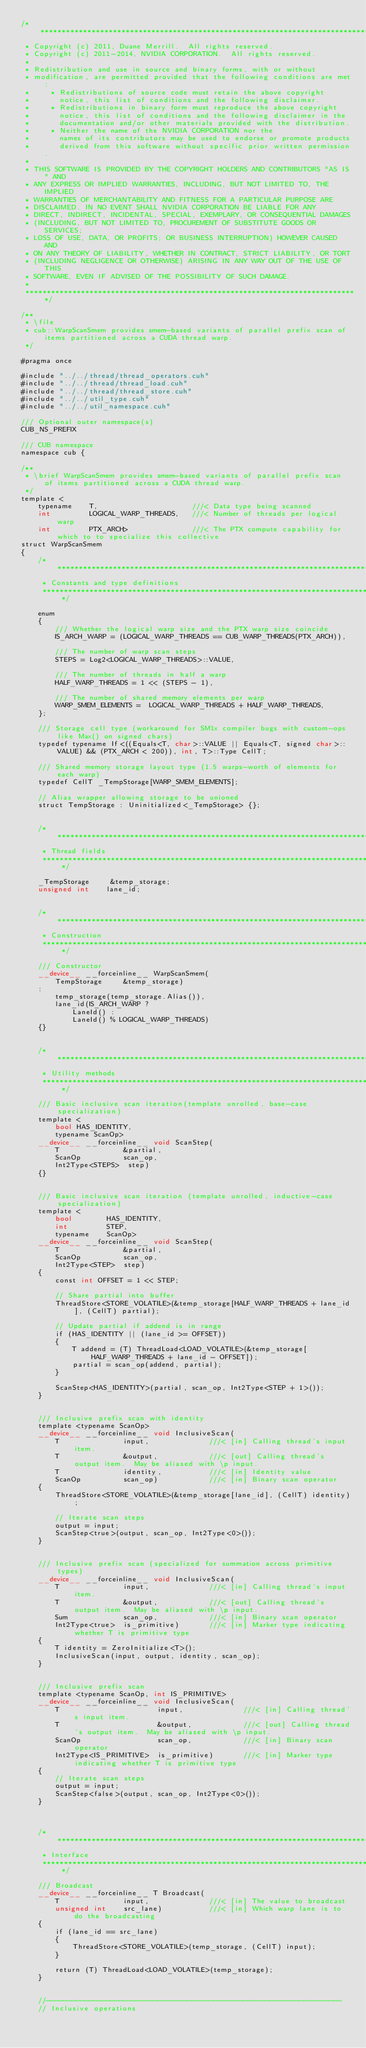Convert code to text. <code><loc_0><loc_0><loc_500><loc_500><_Cuda_>/******************************************************************************
 * Copyright (c) 2011, Duane Merrill.  All rights reserved.
 * Copyright (c) 2011-2014, NVIDIA CORPORATION.  All rights reserved.
 * 
 * Redistribution and use in source and binary forms, with or without
 * modification, are permitted provided that the following conditions are met:
 *     * Redistributions of source code must retain the above copyright
 *       notice, this list of conditions and the following disclaimer.
 *     * Redistributions in binary form must reproduce the above copyright
 *       notice, this list of conditions and the following disclaimer in the
 *       documentation and/or other materials provided with the distribution.
 *     * Neither the name of the NVIDIA CORPORATION nor the
 *       names of its contributors may be used to endorse or promote products
 *       derived from this software without specific prior written permission.
 * 
 * THIS SOFTWARE IS PROVIDED BY THE COPYRIGHT HOLDERS AND CONTRIBUTORS "AS IS" AND
 * ANY EXPRESS OR IMPLIED WARRANTIES, INCLUDING, BUT NOT LIMITED TO, THE IMPLIED
 * WARRANTIES OF MERCHANTABILITY AND FITNESS FOR A PARTICULAR PURPOSE ARE
 * DISCLAIMED. IN NO EVENT SHALL NVIDIA CORPORATION BE LIABLE FOR ANY
 * DIRECT, INDIRECT, INCIDENTAL, SPECIAL, EXEMPLARY, OR CONSEQUENTIAL DAMAGES
 * (INCLUDING, BUT NOT LIMITED TO, PROCUREMENT OF SUBSTITUTE GOODS OR SERVICES;
 * LOSS OF USE, DATA, OR PROFITS; OR BUSINESS INTERRUPTION) HOWEVER CAUSED AND
 * ON ANY THEORY OF LIABILITY, WHETHER IN CONTRACT, STRICT LIABILITY, OR TORT
 * (INCLUDING NEGLIGENCE OR OTHERWISE) ARISING IN ANY WAY OUT OF THE USE OF THIS
 * SOFTWARE, EVEN IF ADVISED OF THE POSSIBILITY OF SUCH DAMAGE.
 *
 ******************************************************************************/

/**
 * \file
 * cub::WarpScanSmem provides smem-based variants of parallel prefix scan of items partitioned across a CUDA thread warp.
 */

#pragma once

#include "../../thread/thread_operators.cuh"
#include "../../thread/thread_load.cuh"
#include "../../thread/thread_store.cuh"
#include "../../util_type.cuh"
#include "../../util_namespace.cuh"

/// Optional outer namespace(s)
CUB_NS_PREFIX

/// CUB namespace
namespace cub {

/**
 * \brief WarpScanSmem provides smem-based variants of parallel prefix scan of items partitioned across a CUDA thread warp.
 */
template <
    typename    T,                      ///< Data type being scanned
    int         LOGICAL_WARP_THREADS,   ///< Number of threads per logical warp
    int         PTX_ARCH>               ///< The PTX compute capability for which to to specialize this collective
struct WarpScanSmem
{
    /******************************************************************************
     * Constants and type definitions
     ******************************************************************************/

    enum
    {
        /// Whether the logical warp size and the PTX warp size coincide
        IS_ARCH_WARP = (LOGICAL_WARP_THREADS == CUB_WARP_THREADS(PTX_ARCH)),

        /// The number of warp scan steps
        STEPS = Log2<LOGICAL_WARP_THREADS>::VALUE,

        /// The number of threads in half a warp
        HALF_WARP_THREADS = 1 << (STEPS - 1),

        /// The number of shared memory elements per warp
        WARP_SMEM_ELEMENTS =  LOGICAL_WARP_THREADS + HALF_WARP_THREADS,
    };

    /// Storage cell type (workaround for SM1x compiler bugs with custom-ops like Max() on signed chars)
    typedef typename If<((Equals<T, char>::VALUE || Equals<T, signed char>::VALUE) && (PTX_ARCH < 200)), int, T>::Type CellT;

    /// Shared memory storage layout type (1.5 warps-worth of elements for each warp)
    typedef CellT _TempStorage[WARP_SMEM_ELEMENTS];

    // Alias wrapper allowing storage to be unioned
    struct TempStorage : Uninitialized<_TempStorage> {};


    /******************************************************************************
     * Thread fields
     ******************************************************************************/

    _TempStorage     &temp_storage;
    unsigned int    lane_id;


    /******************************************************************************
     * Construction
     ******************************************************************************/

    /// Constructor
    __device__ __forceinline__ WarpScanSmem(
        TempStorage     &temp_storage)
    :
        temp_storage(temp_storage.Alias()),
        lane_id(IS_ARCH_WARP ?
            LaneId() :
            LaneId() % LOGICAL_WARP_THREADS)
    {}


    /******************************************************************************
     * Utility methods
     ******************************************************************************/

    /// Basic inclusive scan iteration(template unrolled, base-case specialization)
    template <
        bool HAS_IDENTITY,
        typename ScanOp>
    __device__ __forceinline__ void ScanStep(
        T               &partial,
        ScanOp          scan_op,
        Int2Type<STEPS>  step)
    {}


    /// Basic inclusive scan iteration (template unrolled, inductive-case specialization)
    template <
        bool        HAS_IDENTITY,
        int         STEP,
        typename    ScanOp>
    __device__ __forceinline__ void ScanStep(
        T               &partial,
        ScanOp          scan_op,
        Int2Type<STEP>  step)
    {
        const int OFFSET = 1 << STEP;

        // Share partial into buffer
        ThreadStore<STORE_VOLATILE>(&temp_storage[HALF_WARP_THREADS + lane_id], (CellT) partial);

        // Update partial if addend is in range
        if (HAS_IDENTITY || (lane_id >= OFFSET))
        {
            T addend = (T) ThreadLoad<LOAD_VOLATILE>(&temp_storage[HALF_WARP_THREADS + lane_id - OFFSET]);
            partial = scan_op(addend, partial);
        }

        ScanStep<HAS_IDENTITY>(partial, scan_op, Int2Type<STEP + 1>());
    }


    /// Inclusive prefix scan with identity
    template <typename ScanOp>
    __device__ __forceinline__ void InclusiveScan(
        T               input,              ///< [in] Calling thread's input item.
        T               &output,            ///< [out] Calling thread's output item.  May be aliased with \p input.
        T               identity,           ///< [in] Identity value
        ScanOp          scan_op)            ///< [in] Binary scan operator
    {
        ThreadStore<STORE_VOLATILE>(&temp_storage[lane_id], (CellT) identity);

        // Iterate scan steps
        output = input;
        ScanStep<true>(output, scan_op, Int2Type<0>());
    }


    /// Inclusive prefix scan (specialized for summation across primitive types)
    __device__ __forceinline__ void InclusiveScan(
        T               input,              ///< [in] Calling thread's input item.
        T               &output,            ///< [out] Calling thread's output item.  May be aliased with \p input.
        Sum             scan_op,            ///< [in] Binary scan operator
        Int2Type<true>  is_primitive)       ///< [in] Marker type indicating whether T is primitive type
    {
        T identity = ZeroInitialize<T>();
        InclusiveScan(input, output, identity, scan_op);
    }


    /// Inclusive prefix scan
    template <typename ScanOp, int IS_PRIMITIVE>
    __device__ __forceinline__ void InclusiveScan(
        T                       input,              ///< [in] Calling thread's input item.
        T                       &output,            ///< [out] Calling thread's output item.  May be aliased with \p input.
        ScanOp                  scan_op,            ///< [in] Binary scan operator
        Int2Type<IS_PRIMITIVE>  is_primitive)       ///< [in] Marker type indicating whether T is primitive type
    {
        // Iterate scan steps
        output = input;
        ScanStep<false>(output, scan_op, Int2Type<0>());
    }



    /******************************************************************************
     * Interface
     ******************************************************************************/

    /// Broadcast
    __device__ __forceinline__ T Broadcast(
        T               input,              ///< [in] The value to broadcast
        unsigned int    src_lane)           ///< [in] Which warp lane is to do the broadcasting
    {
        if (lane_id == src_lane)
        {
            ThreadStore<STORE_VOLATILE>(temp_storage, (CellT) input);
        }

        return (T) ThreadLoad<LOAD_VOLATILE>(temp_storage);
    }


    //---------------------------------------------------------------------
    // Inclusive operations</code> 